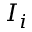<formula> <loc_0><loc_0><loc_500><loc_500>I _ { i }</formula> 